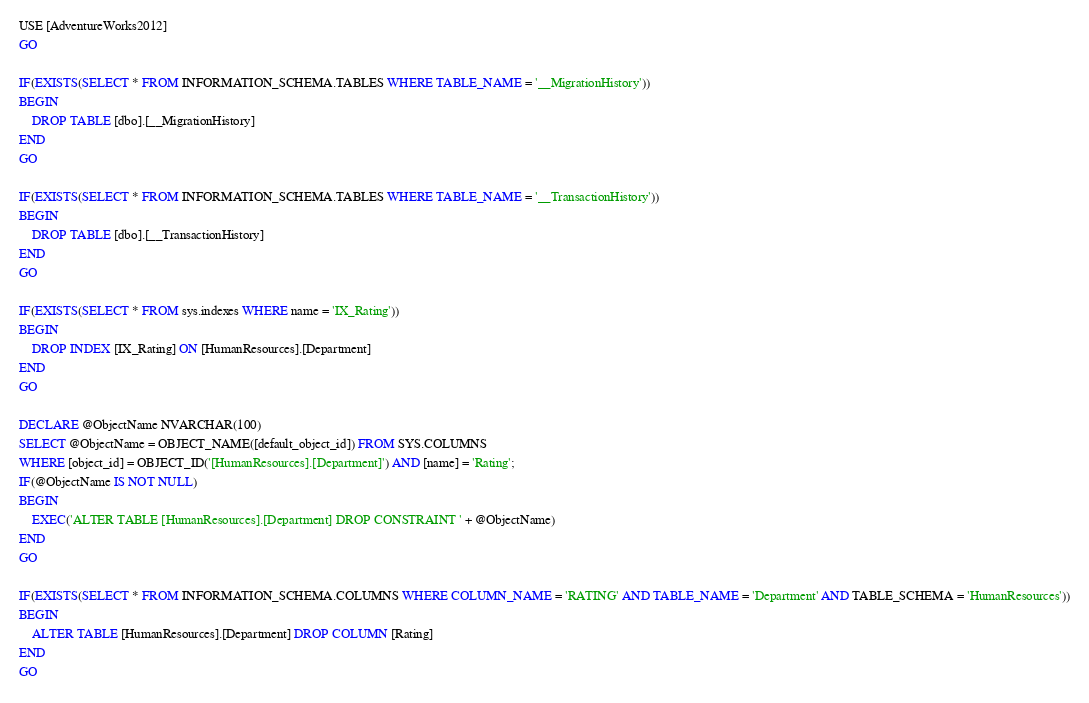<code> <loc_0><loc_0><loc_500><loc_500><_SQL_>USE [AdventureWorks2012]
GO

IF(EXISTS(SELECT * FROM INFORMATION_SCHEMA.TABLES WHERE TABLE_NAME = '__MigrationHistory'))
BEGIN
	DROP TABLE [dbo].[__MigrationHistory]
END
GO

IF(EXISTS(SELECT * FROM INFORMATION_SCHEMA.TABLES WHERE TABLE_NAME = '__TransactionHistory'))
BEGIN
	DROP TABLE [dbo].[__TransactionHistory]
END
GO

IF(EXISTS(SELECT * FROM sys.indexes WHERE name = 'IX_Rating'))
BEGIN
	DROP INDEX [IX_Rating] ON [HumanResources].[Department]
END
GO

DECLARE @ObjectName NVARCHAR(100)
SELECT @ObjectName = OBJECT_NAME([default_object_id]) FROM SYS.COLUMNS
WHERE [object_id] = OBJECT_ID('[HumanResources].[Department]') AND [name] = 'Rating';
IF(@ObjectName IS NOT NULL) 
BEGIN 
	EXEC('ALTER TABLE [HumanResources].[Department] DROP CONSTRAINT ' + @ObjectName)
END
GO

IF(EXISTS(SELECT * FROM INFORMATION_SCHEMA.COLUMNS WHERE COLUMN_NAME = 'RATING' AND TABLE_NAME = 'Department' AND TABLE_SCHEMA = 'HumanResources'))
BEGIN
	ALTER TABLE [HumanResources].[Department] DROP COLUMN [Rating]
END
GO</code> 